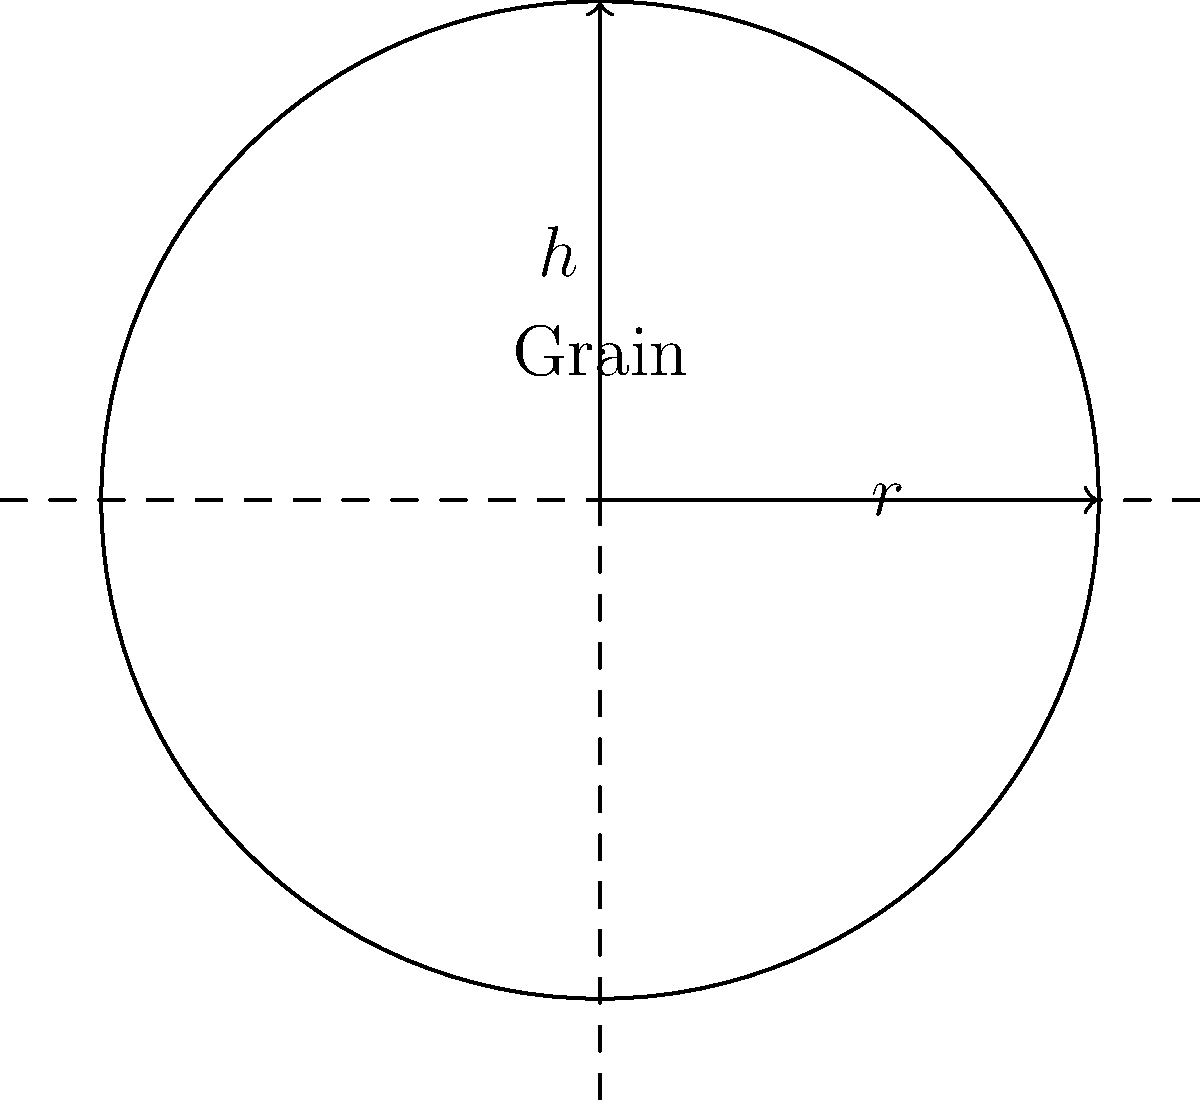As a farmer who has implemented sustainable farming techniques, you're storing grain in a cylindrical silo. The silo has a radius $r$ of 3 meters and is filled to a height $h$ of 10 meters. If the density of the grain is 800 kg/m³ and gravitational acceleration is 9.8 m/s², what is the pressure exerted by the grain at the bottom of the silo? To solve this problem, we'll follow these steps:

1) First, recall the formula for pressure at the bottom of a fluid column:
   $$P = \rho gh$$
   where $P$ is pressure, $\rho$ is density, $g$ is gravitational acceleration, and $h$ is height.

2) We're given:
   - Density ($\rho$) = 800 kg/m³
   - Gravitational acceleration ($g$) = 9.8 m/s²
   - Height ($h$) = 10 m

3) Substitute these values into the equation:
   $$P = 800 \text{ kg/m³} \times 9.8 \text{ m/s²} \times 10 \text{ m}$$

4) Multiply the numbers:
   $$P = 78,400 \text{ kg/(m·s²)}$$

5) The unit kg/(m·s²) is equivalent to Pascal (Pa). So our final answer is:
   $$P = 78,400 \text{ Pa}$$

Note: This calculation assumes the grain behaves like a fluid, which is a reasonable approximation for many granular materials in storage.
Answer: 78,400 Pa 